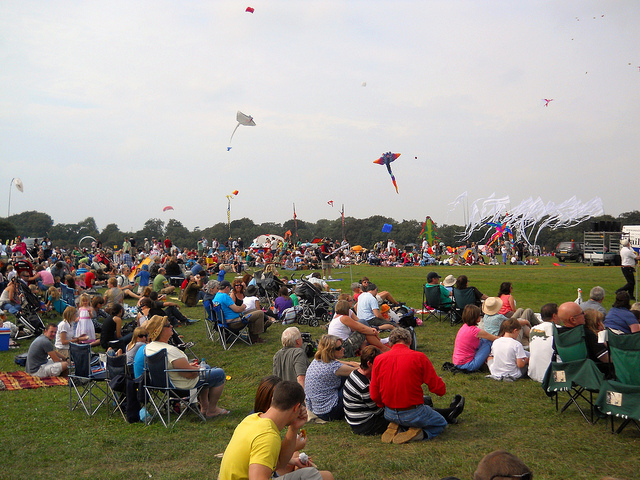What is the occasion that has brought this large group of people together in an outdoor setting? The image suggests that we are looking at a kite festival or an outdoor event dedicated to kite flying. Such gatherings often attract kite enthusiasts and their families, creating an atmosphere of shared enjoyment and community spirit. Can you describe the kind of kites visible in the sky? Certainly! There is a variety of kites soaring high, with an array of shapes and sizes. Some kites have bold colors and intricate designs, likely to stand out against the backdrop of the sky, while others may have simpler shapes that are optimized for easy flying. 